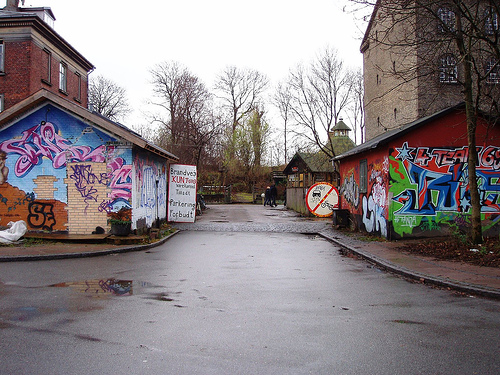<image>
Is the sign in front of the trashcan? No. The sign is not in front of the trashcan. The spatial positioning shows a different relationship between these objects. 